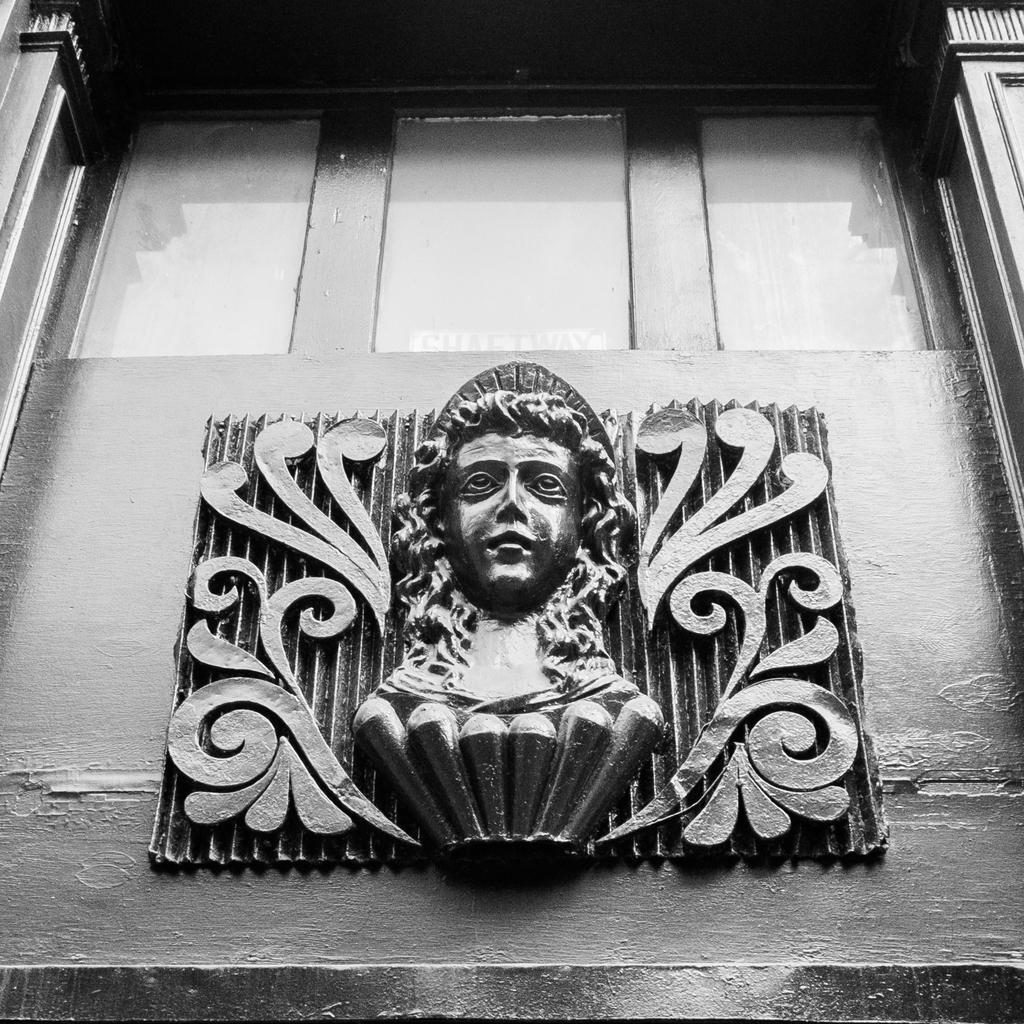What is the main subject of the image? The main subject of the image is a small face statue. Where is the statue located in the image? The statue is attached to a wall. What other elements can be seen in the image? There is a glass element and a wooden window in the image. What type of nut is being used to hold the wooden window in place? There is no nut visible in the image, and the wooden window is not being held in place by any nuts. 